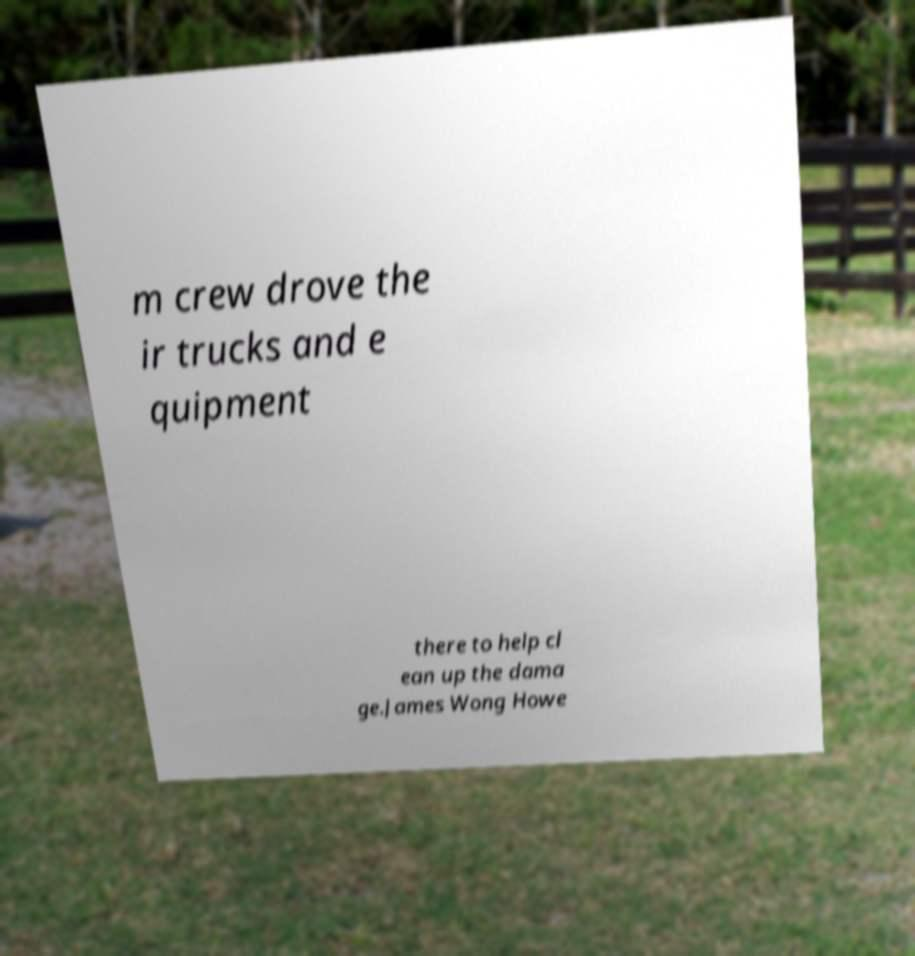For documentation purposes, I need the text within this image transcribed. Could you provide that? m crew drove the ir trucks and e quipment there to help cl ean up the dama ge.James Wong Howe 